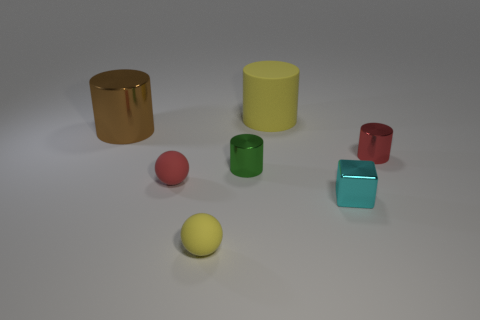Add 1 small blue shiny balls. How many objects exist? 8 Subtract all rubber cylinders. How many cylinders are left? 3 Subtract 3 cylinders. How many cylinders are left? 1 Subtract all yellow cylinders. How many cylinders are left? 3 Subtract 0 cyan cylinders. How many objects are left? 7 Subtract all blocks. How many objects are left? 6 Subtract all blue cubes. Subtract all purple spheres. How many cubes are left? 1 Subtract all tiny yellow balls. Subtract all cyan metallic objects. How many objects are left? 5 Add 7 small rubber objects. How many small rubber objects are left? 9 Add 5 small red shiny cylinders. How many small red shiny cylinders exist? 6 